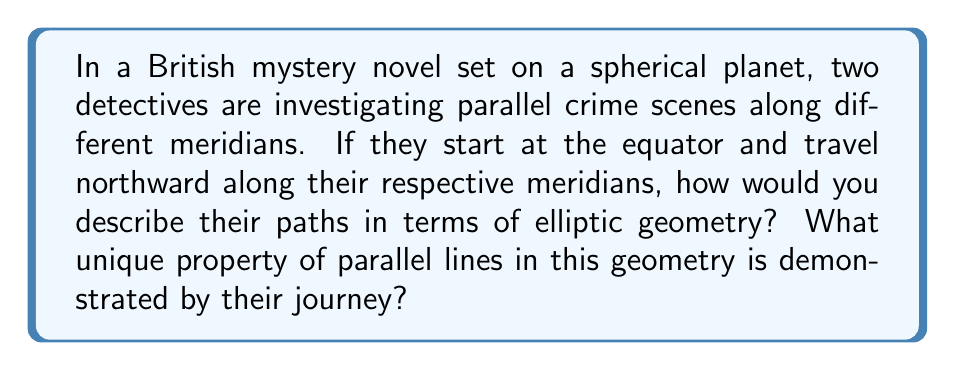Solve this math problem. Let's analyze this step-by-step:

1) In elliptic geometry, which is modeled on the surface of a sphere, the concept of parallel lines is fundamentally different from Euclidean geometry.

2) On a sphere, meridians (lines of longitude) are great circles that all intersect at the poles. In elliptic geometry, these are considered "straight lines."

3) In Euclidean geometry, parallel lines never intersect. However, in elliptic geometry:

   $$\text{All "straight lines" intersect at two antipodal points}$$

4) The detectives' paths along different meridians represent "parallel lines" in elliptic geometry because:
   
   a) They start perpendicular to the equator (another great circle)
   b) They maintain a constant distance from each other along the equator

5) As the detectives travel northward:
   
   $$\text{Distance between paths} = R \cdot \Delta\lambda \cdot \cos(\phi)$$
   
   Where $R$ is the radius of the sphere, $\Delta\lambda$ is the longitude difference, and $\phi$ is the latitude.

6) This distance decreases as latitude increases, until:

   $$\lim_{\phi \to 90°} R \cdot \Delta\lambda \cdot \cos(\phi) = 0$$

7) The detectives' paths will eventually intersect at the North Pole, demonstrating that in elliptic geometry:

   $$\text{Parallel lines converge and intersect}$$

This property is unique to elliptic geometry and contradicts Euclid's parallel postulate.
Answer: Parallel lines converge and intersect at antipodal points. 